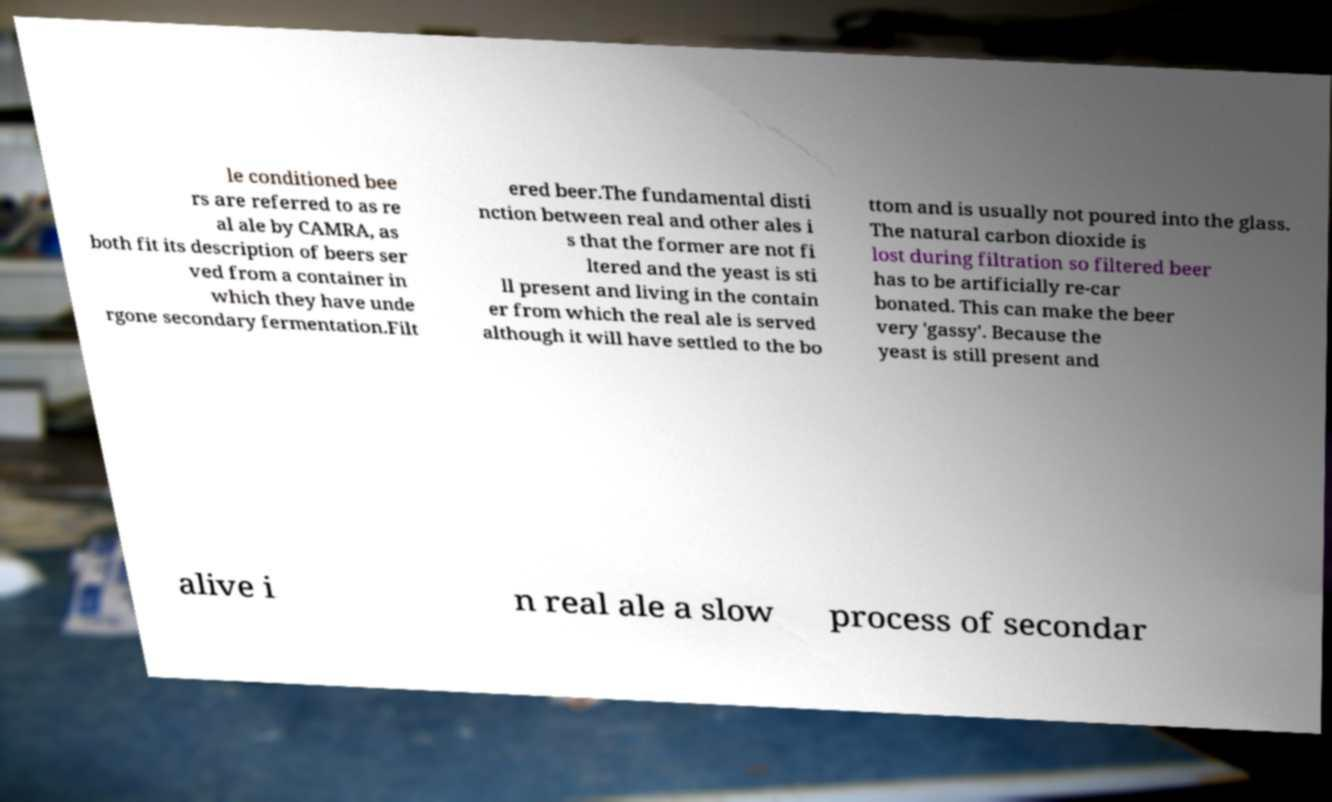There's text embedded in this image that I need extracted. Can you transcribe it verbatim? le conditioned bee rs are referred to as re al ale by CAMRA, as both fit its description of beers ser ved from a container in which they have unde rgone secondary fermentation.Filt ered beer.The fundamental disti nction between real and other ales i s that the former are not fi ltered and the yeast is sti ll present and living in the contain er from which the real ale is served although it will have settled to the bo ttom and is usually not poured into the glass. The natural carbon dioxide is lost during filtration so filtered beer has to be artificially re-car bonated. This can make the beer very 'gassy'. Because the yeast is still present and alive i n real ale a slow process of secondar 